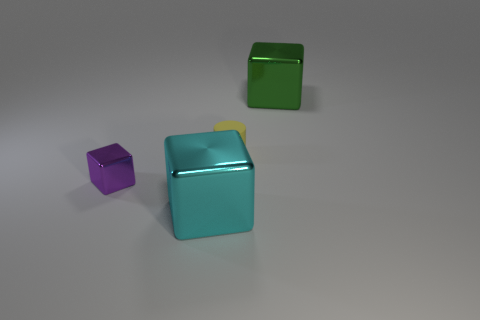There is a metal cube that is the same size as the matte cylinder; what color is it? The cube that matches the size of the matte cylinder is primarily a shade of turquoise, exhibiting a slightly reflective surface that contrasts with the cylinder's matte texture. 